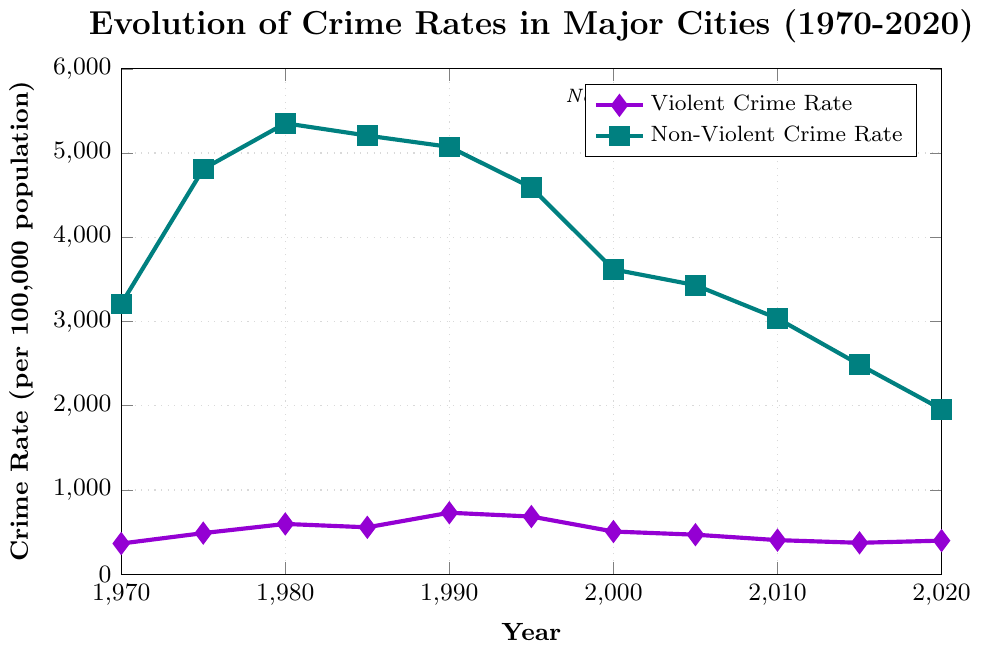What is the violent crime rate in 1990? The figure has a plot for the violent crime rate. By locating the year 1990 on the x-axis and finding the corresponding point on the violent crime line, we can read that the rate is 729.6.
Answer: 729.6 Which year had the highest non-violent crime rate? To find the year with the highest non-violent crime rate, look for the peak of the non-violent crime rate line. This peak occurs in 1980.
Answer: 1980 By how much did the violent crime rate change from 1970 to 2020? Find the difference in the violent crime rates for 1970 and 2020 by subtracting the 1970 rate (364.0) from the 2020 rate (398.5). The change is calculated as follows: 398.5 - 364.0 = 34.5.
Answer: 34.5 What's the average non-violent crime rate over the 50 years? To find the average, sum the non-violent crime rates for all years and divide by the number of years. The calculation is (3207.6 + 4810.7 + 5353.3 + 5207.1 + 5073.1 + 4590.5 + 3618.3 + 3431.5 + 3036.1 + 2487.0 + 1958.2) / 11 = 3824.845
Answer: 3824.845 In which year was the difference between violent and non-violent crime rates the greatest? Calculate the difference between the non-violent and violent crime rates for each year and identify the year with the maximum difference. The greatest difference is in 1980 with rates of 5353.3 and 596.6, respectively: 5353.3 - 596.6 = 4756.7.
Answer: 1980 What general trend can be observed for both violent and non-violent crime rates since the 1990s? Observe the overall direction of the lines for violent and non-violent crime rates since the 1990s. Both lines show a general downward trend.
Answer: A general decline Which type of crime saw a larger decrease from 1995 to 2020? Calculate the decrease for both violent and non-violent crime rates from 1995 to 2020. For violent crime, the decrease is 684.5 - 398.5 = 286. For non-violent crime, the decrease is 4590.5 - 1958.2 = 2632.3. Non-violent crime saw a larger decrease.
Answer: Non-violent crime What color represents the violent crime rate line in the chart? The visual attribute related to the color of the line representing violent crime rates is described in the label. The line is violet in color.
Answer: Violet 